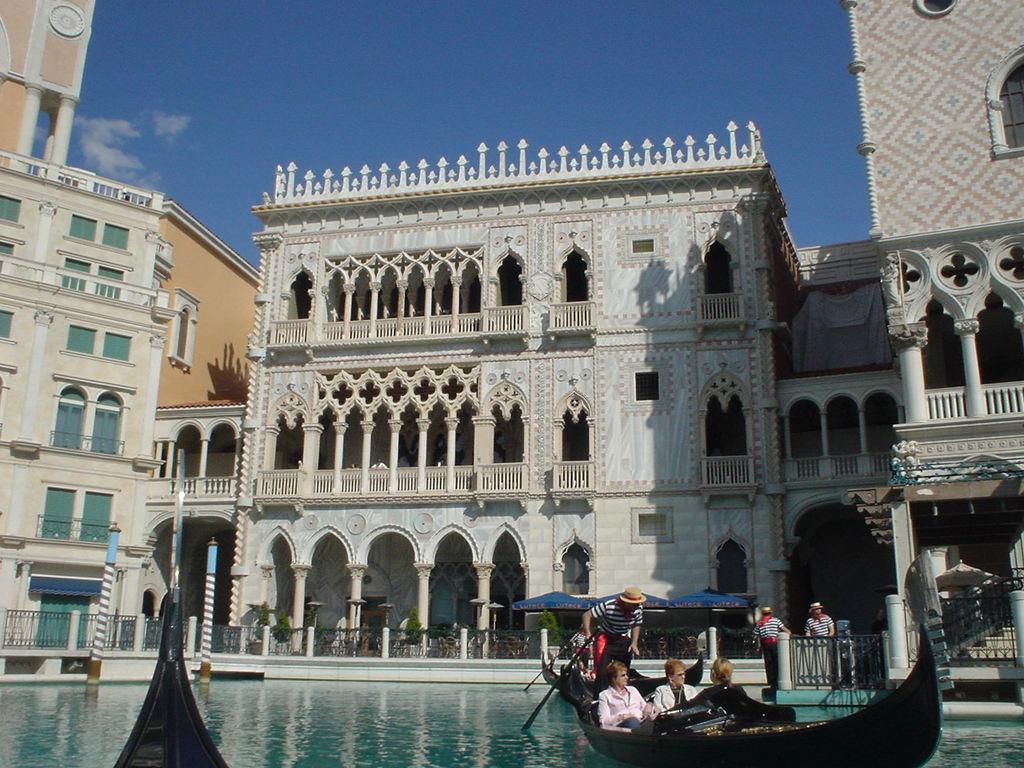Describe this image in one or two sentences. There are four persons riding a boat. This is water and there are few persons. In the background we can see buildings, fence, plants, pillars, and sky. 